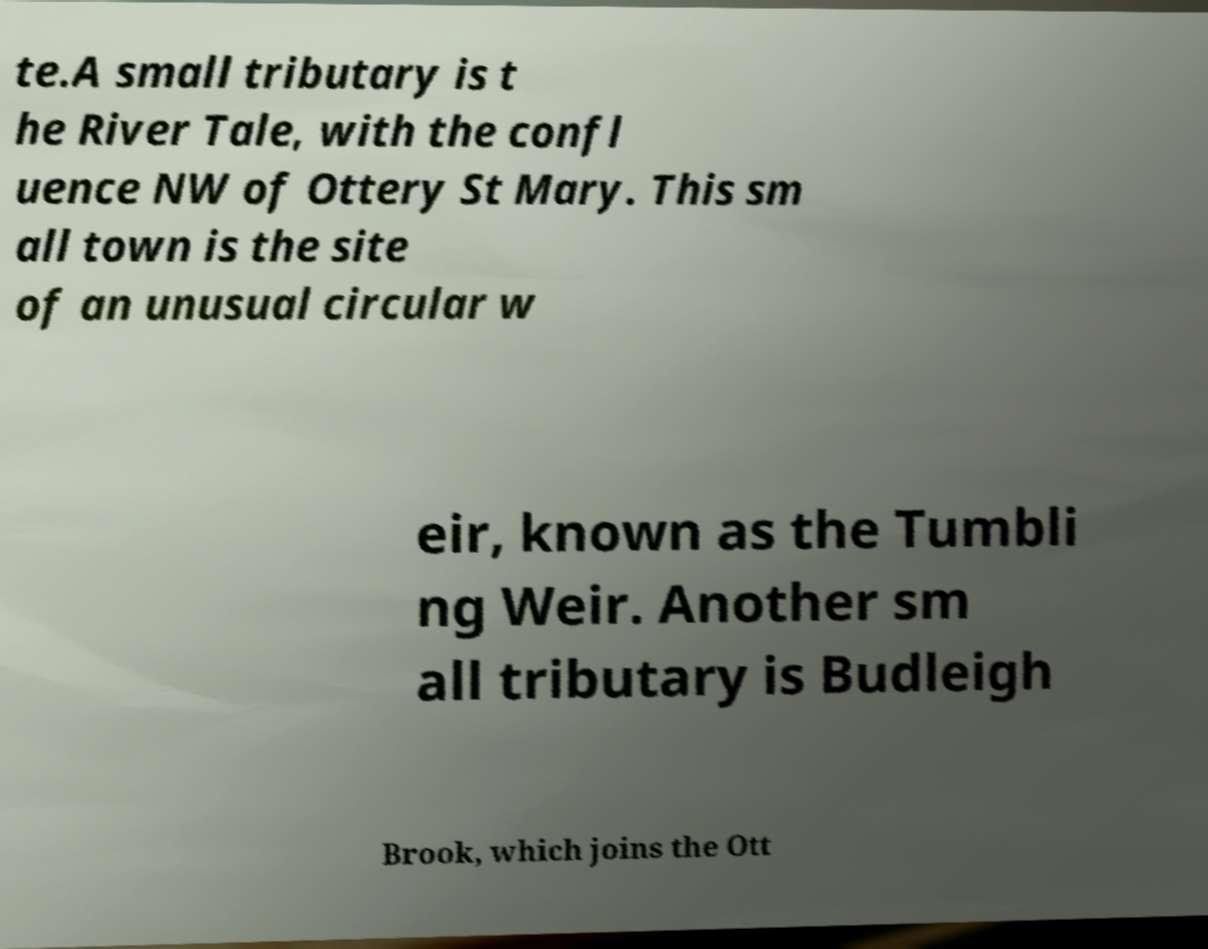What messages or text are displayed in this image? I need them in a readable, typed format. te.A small tributary is t he River Tale, with the confl uence NW of Ottery St Mary. This sm all town is the site of an unusual circular w eir, known as the Tumbli ng Weir. Another sm all tributary is Budleigh Brook, which joins the Ott 